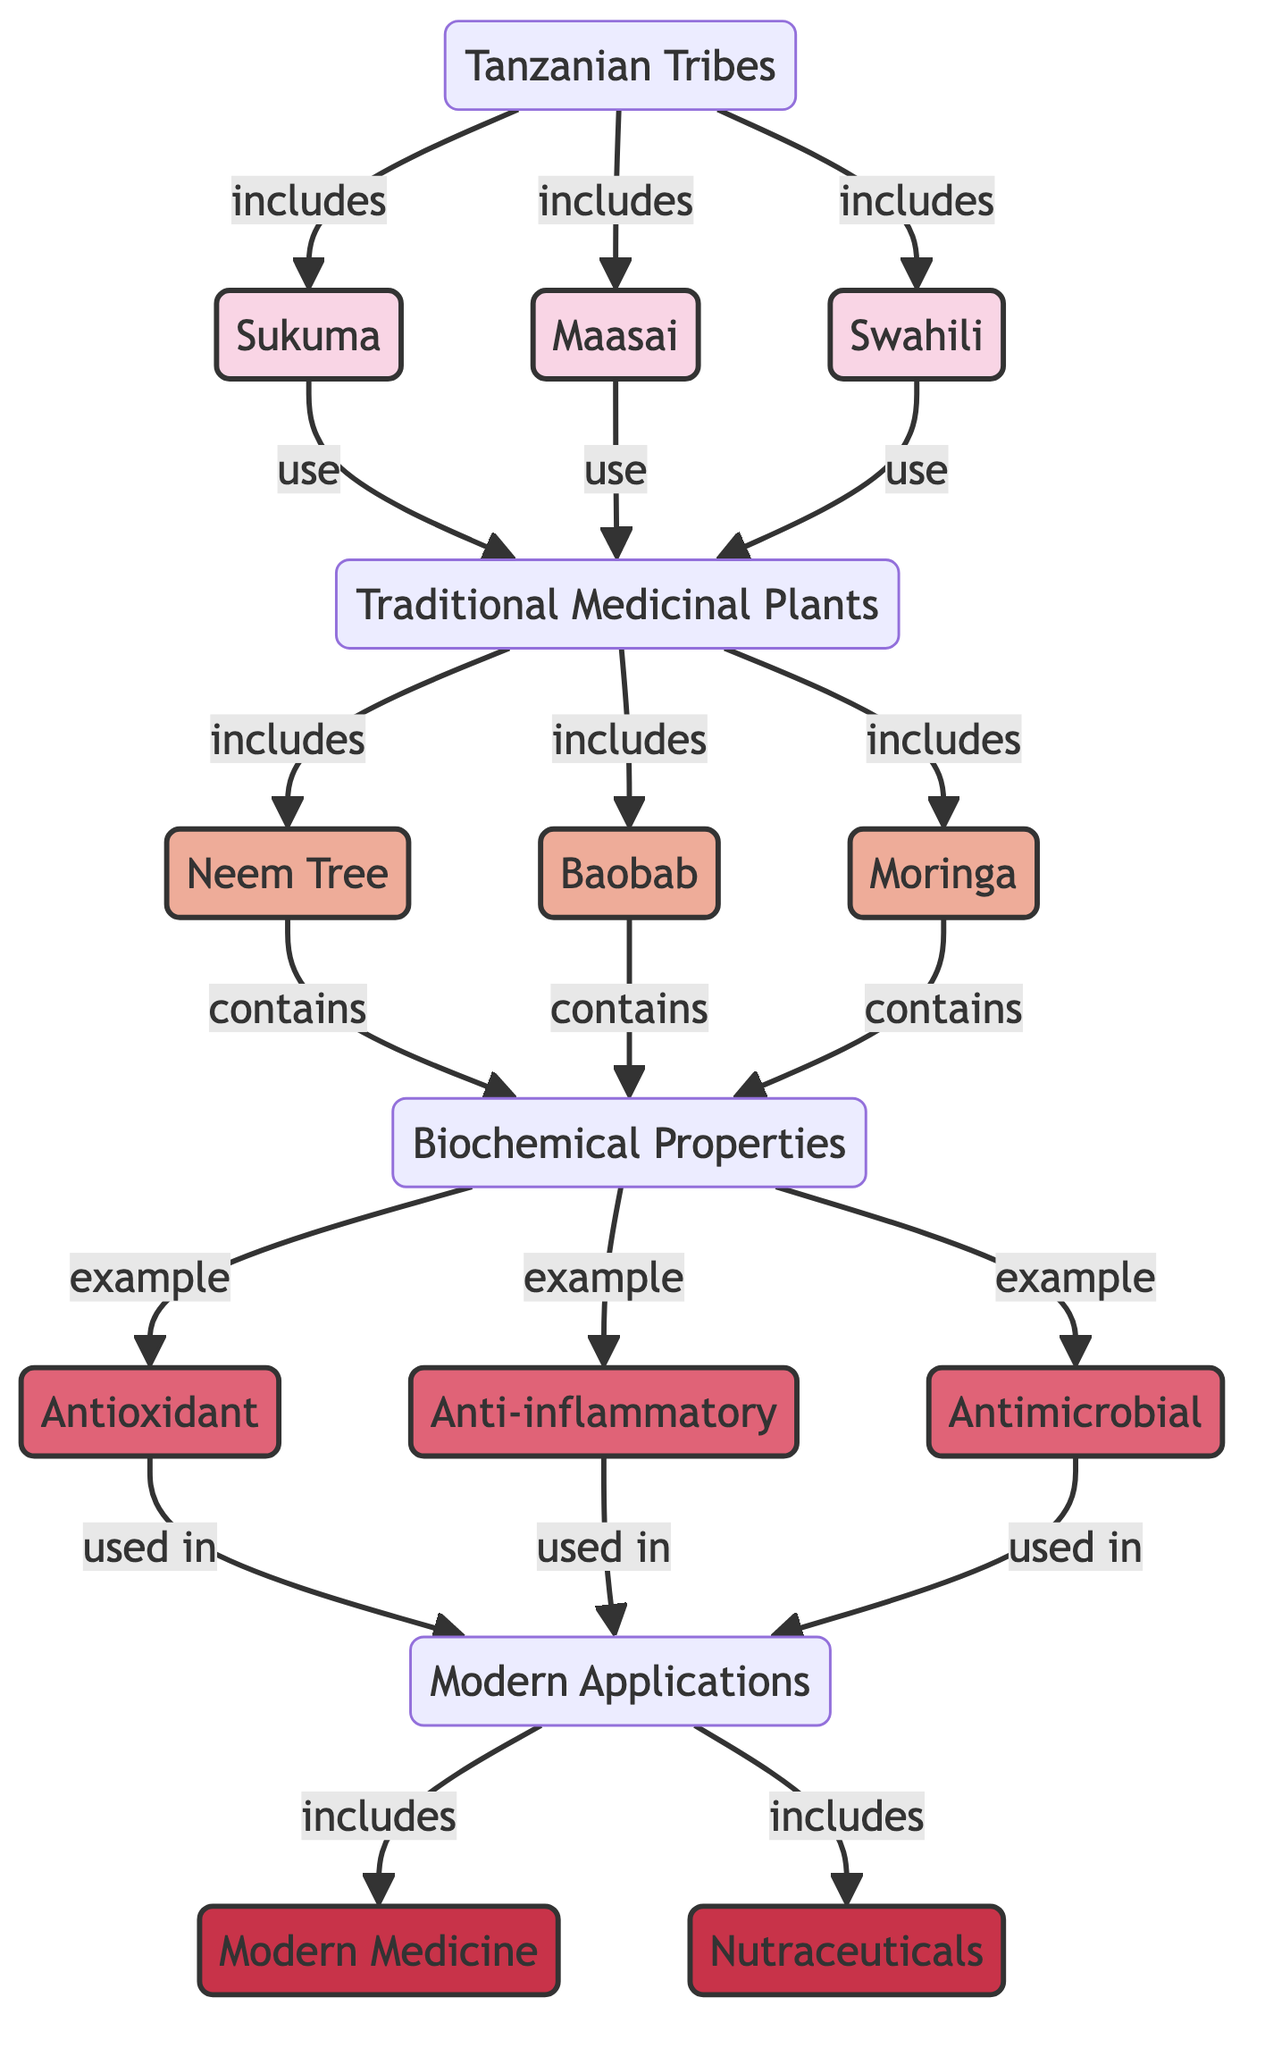What are the three tribes mentioned in the diagram? The diagram shows three specific tribes: Sukuma, Maasai, and Swahili. These are directly linked to the node representing Tanzanian tribes.
Answer: Sukuma, Maasai, Swahili How many traditional medicinal plants are listed? There are three traditional medicinal plants: Neem Tree, Baobab, and Moringa, which are explicitly enumerated in the plant node.
Answer: 3 What is one of the biochemical properties associated with the plants? The diagram indicates several biochemical properties; one example is the "Antioxidant" property connected to the plants via the biochemical node.
Answer: Antioxidant Which modern application is linked to the biochemical properties? Both "Modern Medicine" and "Nutraceuticals" are mentioned as applications that use the biochemical properties, illustrating how these properties are relevant today.
Answer: Modern Medicine What type of relationship exists between the traditional plants and the tribes? The diagram denotes that the tribes "use" the traditional medicinal plants, creating a direct connection between the two groups in terms of usage.
Answer: use How many biochemical properties are identified in the diagram? The diagram outlines three specific biochemical properties: Antioxidant, Anti-inflammatory, and Antimicrobial, which are linked under the biochemical node.
Answer: 3 What is the connection between traditional medicinal plants and modern applications? The diagram illustrates that the plants contain biochemical properties, which shows how they are linked to modern applications such as medicine and nutraceuticals.
Answer: contain Which tribe is associated with the use of the Moringa plant? In the diagram, it does not specify a single tribe that uses Moringa; however, it indicates that all listed tribes (Sukuma, Maasai, and Swahili) use traditional medicinal plants, including Moringa.
Answer: All tribes What color represents the traditional medicinal plants in the diagram? The traditional medicinal plants are represented by a specific color in the diagram: light pink (#eeac99). This visual aspect distinguishes them from other components of the diagram.
Answer: light pink 